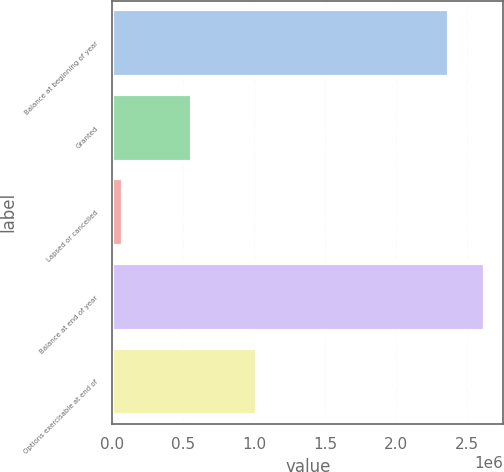<chart> <loc_0><loc_0><loc_500><loc_500><bar_chart><fcel>Balance at beginning of year<fcel>Granted<fcel>Lapsed or cancelled<fcel>Balance at end of year<fcel>Options exercisable at end of<nl><fcel>2.37182e+06<fcel>561000<fcel>74664<fcel>2.62416e+06<fcel>1.02264e+06<nl></chart> 